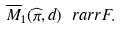Convert formula to latex. <formula><loc_0><loc_0><loc_500><loc_500>\overline { M } _ { 1 } ( \widehat { \pi } , d ) \ r a r r F .</formula> 